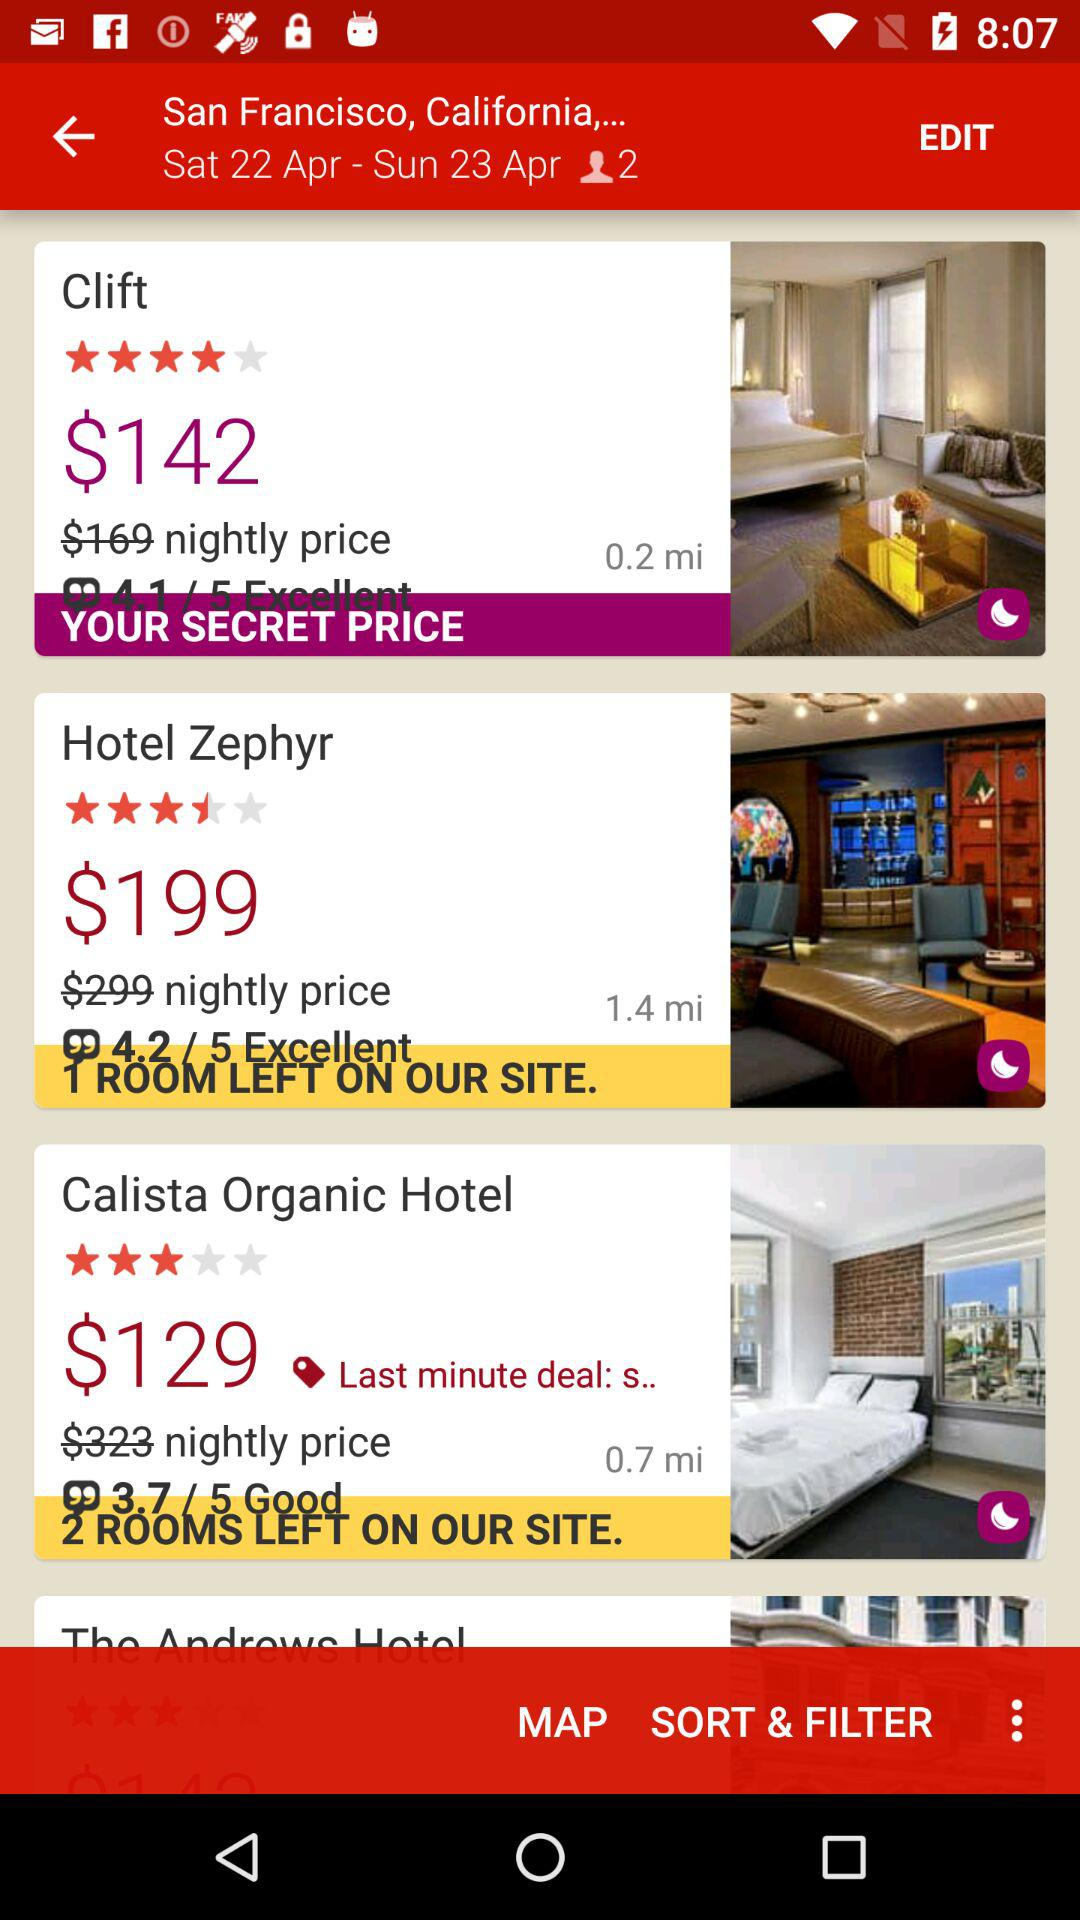What is the price per night of "Clift"? The per night price is $142. 